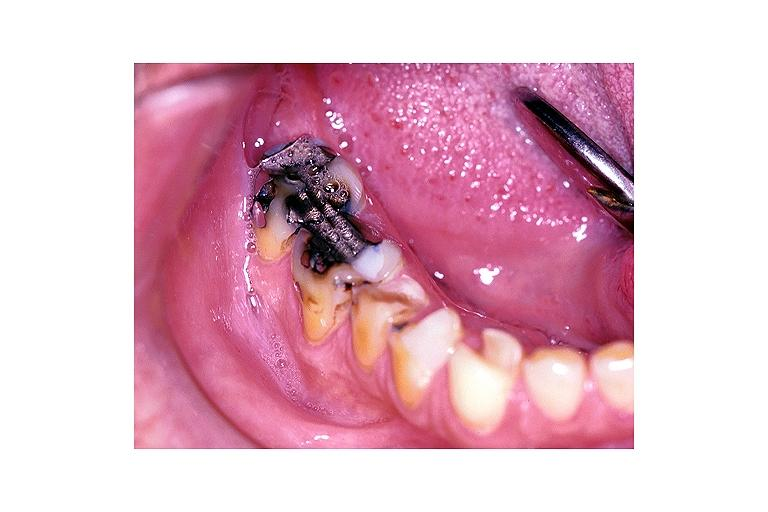does the superior vena cava show severe abrasion?
Answer the question using a single word or phrase. No 